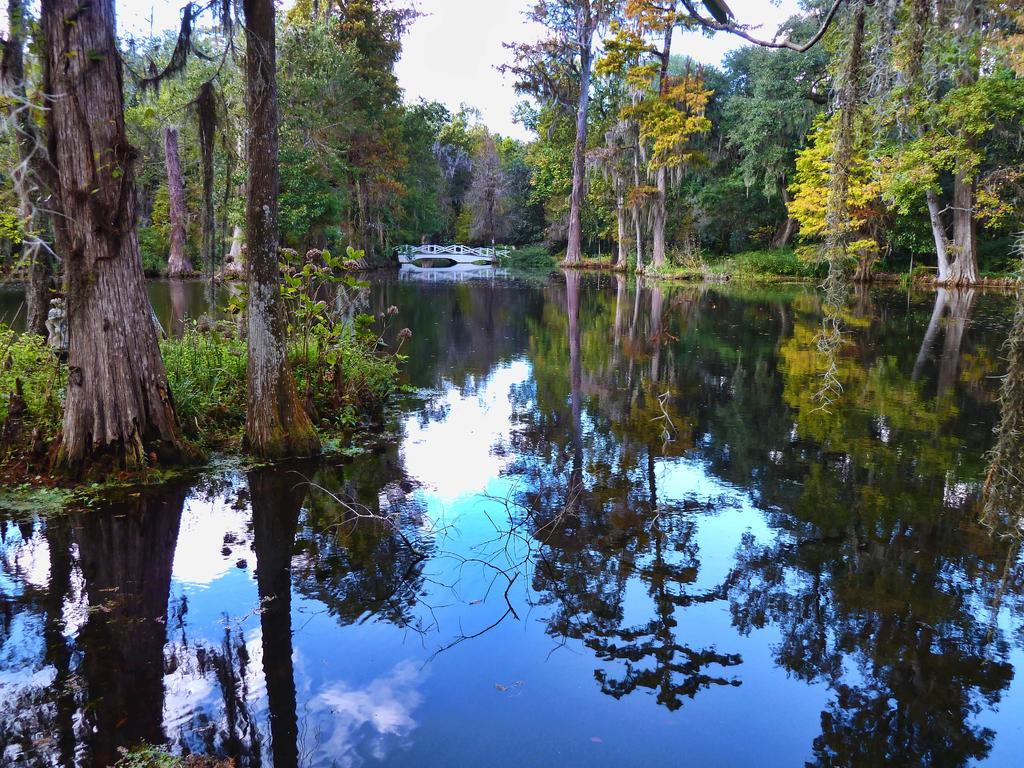What is the primary element in the image? The image consists of water. What can be seen in the background of the image? There are many trees in the background. What is visible at the top of the image? The sky is visible at the top of the image. Reasoning: Let' Let's think step by step in order to produce the conversation. We start by identifying the main element in the image, which is water. Then, we expand the conversation to include other elements that are also visible, such as the trees in the background and the sky at the top of the image. Each question is designed to elicit a specific detail about the image that is known from the provided facts. Absurd Question/Answer: What type of meal is being prepared in the image? There is no meal preparation visible in the image; it consists of water, trees, and the sky. How many clocks are hanging on the trees in the image? There are no clocks hanging on the trees in the image; it consists of water, trees, and the sky. 